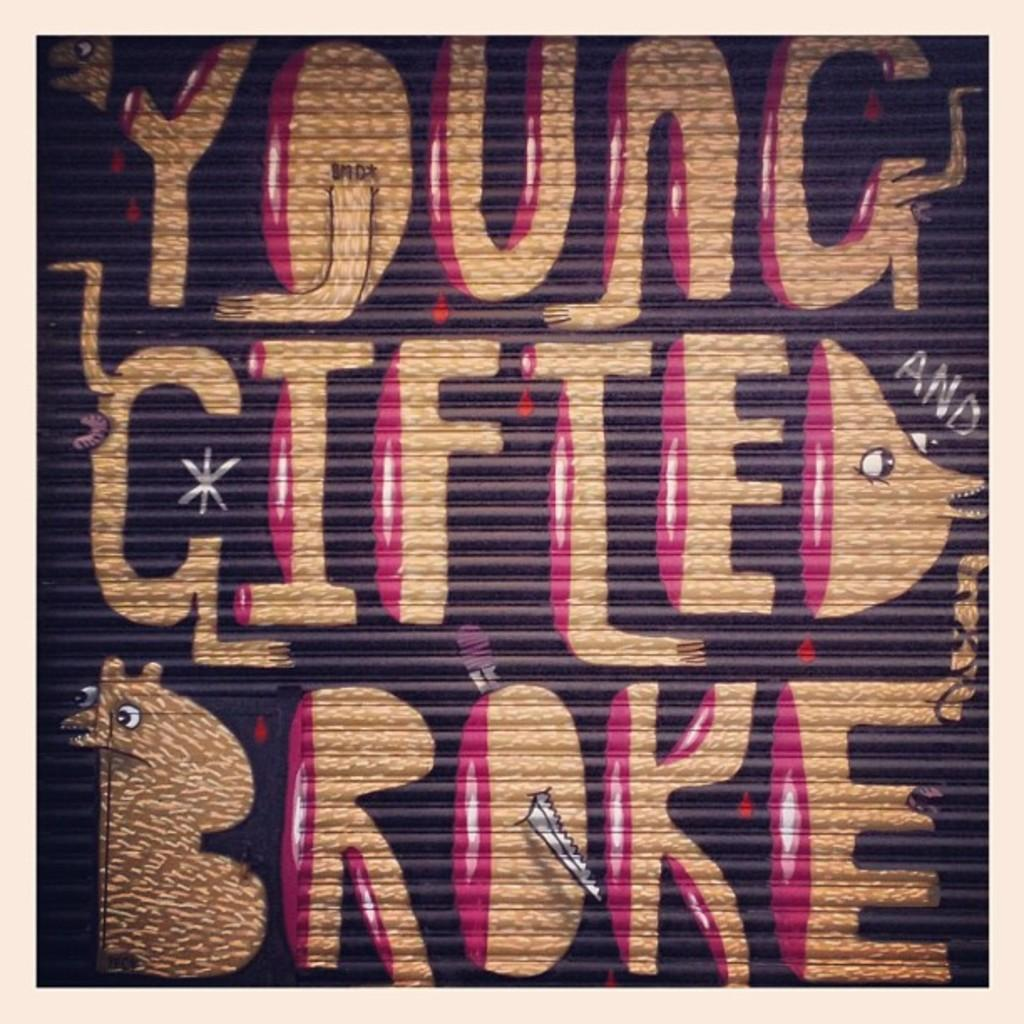<image>
Provide a brief description of the given image. An artistic poster that reads, young, gifted, and broke. 